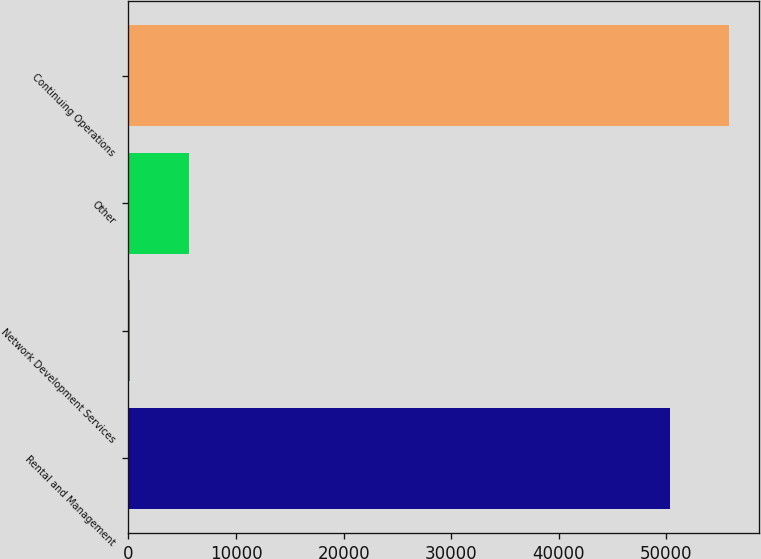Convert chart. <chart><loc_0><loc_0><loc_500><loc_500><bar_chart><fcel>Rental and Management<fcel>Network Development Services<fcel>Other<fcel>Continuing Operations<nl><fcel>50336<fcel>106<fcel>5631.1<fcel>55861.1<nl></chart> 